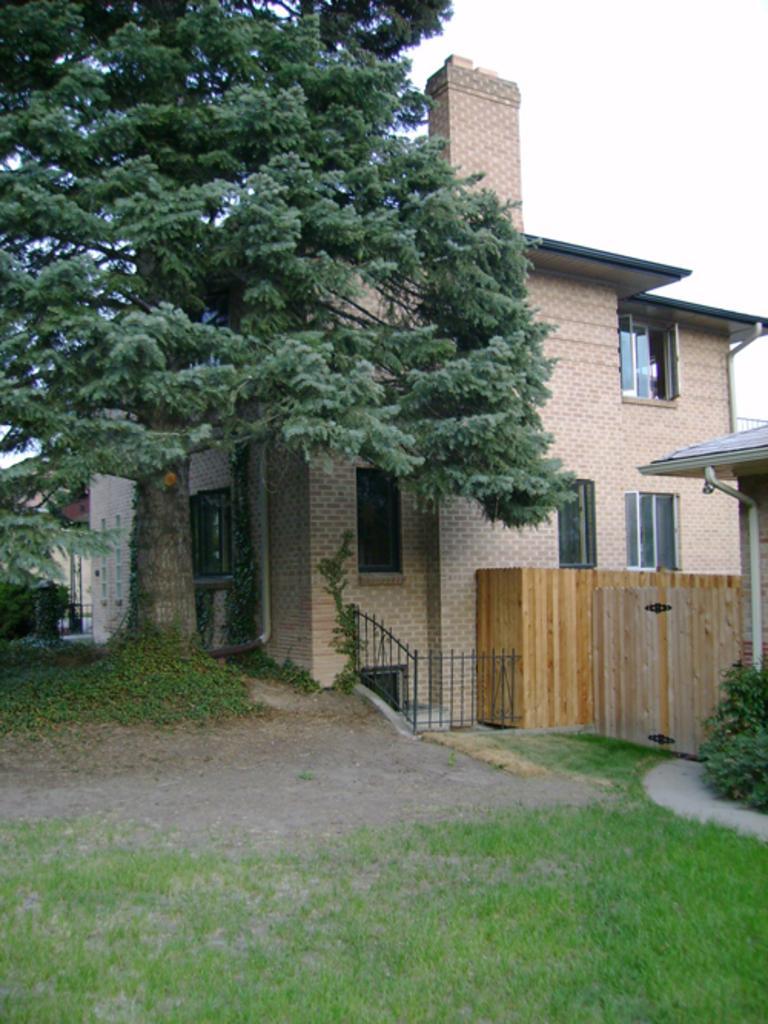Could you give a brief overview of what you see in this image? In this image we can see a building, tree, fence, plants and other objects. On the right side top of the image there is the sky. At the bottom of the image there is the grass. 